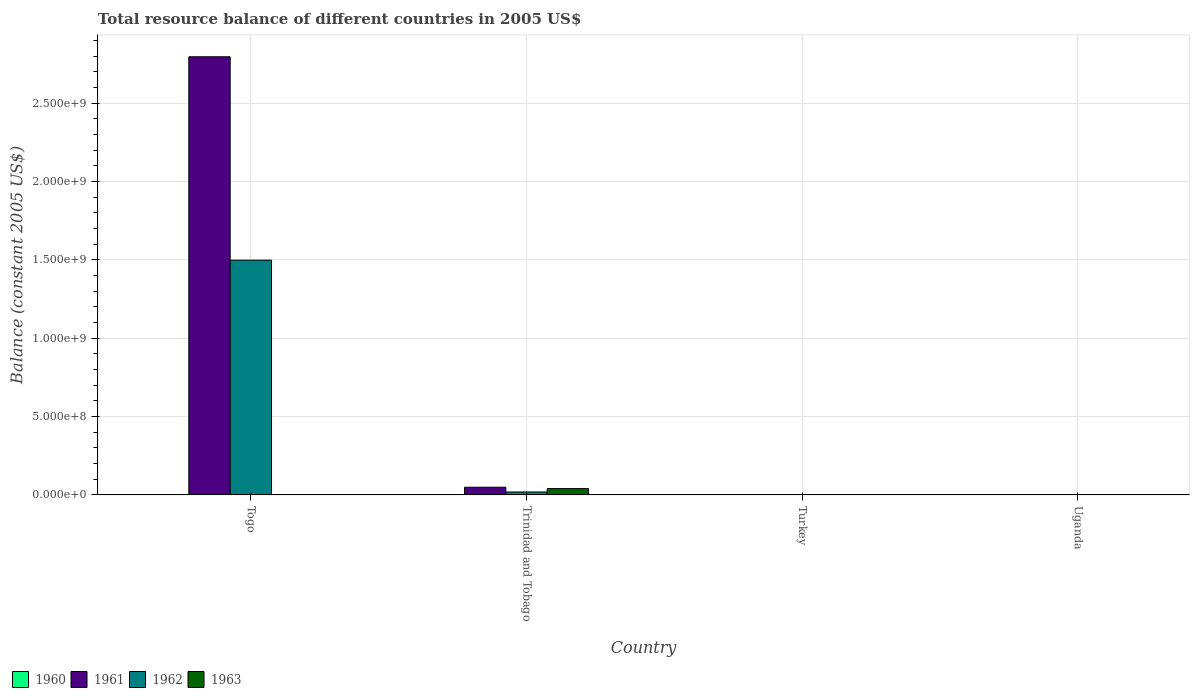How many different coloured bars are there?
Provide a succinct answer. 4. Are the number of bars on each tick of the X-axis equal?
Keep it short and to the point. No. How many bars are there on the 1st tick from the left?
Provide a short and direct response. 2. What is the total resource balance in 1963 in Uganda?
Make the answer very short. 2.17e+06. Across all countries, what is the maximum total resource balance in 1961?
Your answer should be compact. 2.80e+09. In which country was the total resource balance in 1962 maximum?
Provide a short and direct response. Togo. What is the total total resource balance in 1962 in the graph?
Your answer should be very brief. 1.52e+09. What is the difference between the total resource balance in 1963 in Trinidad and Tobago and that in Uganda?
Your answer should be compact. 3.81e+07. What is the difference between the total resource balance in 1962 in Trinidad and Tobago and the total resource balance in 1963 in Uganda?
Give a very brief answer. 1.64e+07. What is the average total resource balance in 1962 per country?
Offer a terse response. 3.79e+08. What is the difference between the total resource balance of/in 1961 and total resource balance of/in 1963 in Trinidad and Tobago?
Your response must be concise. 8.50e+06. What is the ratio of the total resource balance in 1961 in Togo to that in Trinidad and Tobago?
Your response must be concise. 57.29. What is the difference between the highest and the second highest total resource balance in 1961?
Make the answer very short. -2.75e+09. What is the difference between the highest and the lowest total resource balance in 1961?
Ensure brevity in your answer.  2.80e+09. In how many countries, is the total resource balance in 1961 greater than the average total resource balance in 1961 taken over all countries?
Ensure brevity in your answer.  1. Is it the case that in every country, the sum of the total resource balance in 1960 and total resource balance in 1962 is greater than the total resource balance in 1963?
Keep it short and to the point. No. How many bars are there?
Make the answer very short. 9. Are all the bars in the graph horizontal?
Provide a short and direct response. No. How many countries are there in the graph?
Keep it short and to the point. 4. What is the difference between two consecutive major ticks on the Y-axis?
Your answer should be very brief. 5.00e+08. Are the values on the major ticks of Y-axis written in scientific E-notation?
Your answer should be compact. Yes. Does the graph contain any zero values?
Your answer should be compact. Yes. Does the graph contain grids?
Keep it short and to the point. Yes. Where does the legend appear in the graph?
Offer a very short reply. Bottom left. How many legend labels are there?
Provide a succinct answer. 4. What is the title of the graph?
Offer a terse response. Total resource balance of different countries in 2005 US$. Does "1997" appear as one of the legend labels in the graph?
Offer a terse response. No. What is the label or title of the X-axis?
Provide a short and direct response. Country. What is the label or title of the Y-axis?
Give a very brief answer. Balance (constant 2005 US$). What is the Balance (constant 2005 US$) in 1961 in Togo?
Give a very brief answer. 2.80e+09. What is the Balance (constant 2005 US$) in 1962 in Togo?
Provide a succinct answer. 1.50e+09. What is the Balance (constant 2005 US$) of 1963 in Togo?
Give a very brief answer. 0. What is the Balance (constant 2005 US$) of 1961 in Trinidad and Tobago?
Offer a very short reply. 4.88e+07. What is the Balance (constant 2005 US$) in 1962 in Trinidad and Tobago?
Offer a terse response. 1.86e+07. What is the Balance (constant 2005 US$) of 1963 in Trinidad and Tobago?
Your answer should be very brief. 4.03e+07. What is the Balance (constant 2005 US$) of 1960 in Turkey?
Provide a succinct answer. 0. What is the Balance (constant 2005 US$) in 1961 in Turkey?
Your answer should be very brief. 0. What is the Balance (constant 2005 US$) in 1963 in Turkey?
Offer a very short reply. 0. What is the Balance (constant 2005 US$) of 1960 in Uganda?
Provide a succinct answer. 2.22e+06. What is the Balance (constant 2005 US$) in 1961 in Uganda?
Your answer should be compact. 1.17e+06. What is the Balance (constant 2005 US$) of 1962 in Uganda?
Make the answer very short. 1.14e+06. What is the Balance (constant 2005 US$) of 1963 in Uganda?
Your response must be concise. 2.17e+06. Across all countries, what is the maximum Balance (constant 2005 US$) in 1960?
Your answer should be compact. 2.22e+06. Across all countries, what is the maximum Balance (constant 2005 US$) of 1961?
Provide a succinct answer. 2.80e+09. Across all countries, what is the maximum Balance (constant 2005 US$) in 1962?
Provide a succinct answer. 1.50e+09. Across all countries, what is the maximum Balance (constant 2005 US$) in 1963?
Make the answer very short. 4.03e+07. Across all countries, what is the minimum Balance (constant 2005 US$) in 1963?
Ensure brevity in your answer.  0. What is the total Balance (constant 2005 US$) in 1960 in the graph?
Offer a terse response. 2.22e+06. What is the total Balance (constant 2005 US$) in 1961 in the graph?
Your answer should be compact. 2.85e+09. What is the total Balance (constant 2005 US$) in 1962 in the graph?
Give a very brief answer. 1.52e+09. What is the total Balance (constant 2005 US$) of 1963 in the graph?
Ensure brevity in your answer.  4.25e+07. What is the difference between the Balance (constant 2005 US$) in 1961 in Togo and that in Trinidad and Tobago?
Give a very brief answer. 2.75e+09. What is the difference between the Balance (constant 2005 US$) of 1962 in Togo and that in Trinidad and Tobago?
Provide a short and direct response. 1.48e+09. What is the difference between the Balance (constant 2005 US$) in 1961 in Togo and that in Uganda?
Your answer should be compact. 2.79e+09. What is the difference between the Balance (constant 2005 US$) in 1962 in Togo and that in Uganda?
Your answer should be compact. 1.50e+09. What is the difference between the Balance (constant 2005 US$) in 1961 in Trinidad and Tobago and that in Uganda?
Your response must be concise. 4.76e+07. What is the difference between the Balance (constant 2005 US$) of 1962 in Trinidad and Tobago and that in Uganda?
Give a very brief answer. 1.75e+07. What is the difference between the Balance (constant 2005 US$) of 1963 in Trinidad and Tobago and that in Uganda?
Offer a very short reply. 3.81e+07. What is the difference between the Balance (constant 2005 US$) in 1961 in Togo and the Balance (constant 2005 US$) in 1962 in Trinidad and Tobago?
Your answer should be compact. 2.78e+09. What is the difference between the Balance (constant 2005 US$) in 1961 in Togo and the Balance (constant 2005 US$) in 1963 in Trinidad and Tobago?
Keep it short and to the point. 2.76e+09. What is the difference between the Balance (constant 2005 US$) in 1962 in Togo and the Balance (constant 2005 US$) in 1963 in Trinidad and Tobago?
Your answer should be very brief. 1.46e+09. What is the difference between the Balance (constant 2005 US$) of 1961 in Togo and the Balance (constant 2005 US$) of 1962 in Uganda?
Give a very brief answer. 2.79e+09. What is the difference between the Balance (constant 2005 US$) in 1961 in Togo and the Balance (constant 2005 US$) in 1963 in Uganda?
Your response must be concise. 2.79e+09. What is the difference between the Balance (constant 2005 US$) of 1962 in Togo and the Balance (constant 2005 US$) of 1963 in Uganda?
Provide a succinct answer. 1.50e+09. What is the difference between the Balance (constant 2005 US$) in 1961 in Trinidad and Tobago and the Balance (constant 2005 US$) in 1962 in Uganda?
Provide a short and direct response. 4.77e+07. What is the difference between the Balance (constant 2005 US$) in 1961 in Trinidad and Tobago and the Balance (constant 2005 US$) in 1963 in Uganda?
Offer a terse response. 4.66e+07. What is the difference between the Balance (constant 2005 US$) in 1962 in Trinidad and Tobago and the Balance (constant 2005 US$) in 1963 in Uganda?
Provide a succinct answer. 1.64e+07. What is the average Balance (constant 2005 US$) of 1960 per country?
Offer a very short reply. 5.56e+05. What is the average Balance (constant 2005 US$) of 1961 per country?
Your response must be concise. 7.11e+08. What is the average Balance (constant 2005 US$) of 1962 per country?
Provide a short and direct response. 3.79e+08. What is the average Balance (constant 2005 US$) of 1963 per country?
Provide a succinct answer. 1.06e+07. What is the difference between the Balance (constant 2005 US$) in 1961 and Balance (constant 2005 US$) in 1962 in Togo?
Give a very brief answer. 1.30e+09. What is the difference between the Balance (constant 2005 US$) in 1961 and Balance (constant 2005 US$) in 1962 in Trinidad and Tobago?
Keep it short and to the point. 3.02e+07. What is the difference between the Balance (constant 2005 US$) in 1961 and Balance (constant 2005 US$) in 1963 in Trinidad and Tobago?
Ensure brevity in your answer.  8.50e+06. What is the difference between the Balance (constant 2005 US$) in 1962 and Balance (constant 2005 US$) in 1963 in Trinidad and Tobago?
Keep it short and to the point. -2.17e+07. What is the difference between the Balance (constant 2005 US$) of 1960 and Balance (constant 2005 US$) of 1961 in Uganda?
Provide a succinct answer. 1.06e+06. What is the difference between the Balance (constant 2005 US$) of 1960 and Balance (constant 2005 US$) of 1962 in Uganda?
Offer a terse response. 1.09e+06. What is the difference between the Balance (constant 2005 US$) in 1960 and Balance (constant 2005 US$) in 1963 in Uganda?
Give a very brief answer. 5.31e+04. What is the difference between the Balance (constant 2005 US$) of 1961 and Balance (constant 2005 US$) of 1962 in Uganda?
Provide a succinct answer. 2.93e+04. What is the difference between the Balance (constant 2005 US$) of 1961 and Balance (constant 2005 US$) of 1963 in Uganda?
Provide a succinct answer. -1.00e+06. What is the difference between the Balance (constant 2005 US$) of 1962 and Balance (constant 2005 US$) of 1963 in Uganda?
Provide a succinct answer. -1.03e+06. What is the ratio of the Balance (constant 2005 US$) of 1961 in Togo to that in Trinidad and Tobago?
Keep it short and to the point. 57.29. What is the ratio of the Balance (constant 2005 US$) of 1962 in Togo to that in Trinidad and Tobago?
Your answer should be compact. 80.54. What is the ratio of the Balance (constant 2005 US$) of 1961 in Togo to that in Uganda?
Your answer should be compact. 2392.37. What is the ratio of the Balance (constant 2005 US$) in 1962 in Togo to that in Uganda?
Your answer should be very brief. 1314.75. What is the ratio of the Balance (constant 2005 US$) in 1961 in Trinidad and Tobago to that in Uganda?
Keep it short and to the point. 41.76. What is the ratio of the Balance (constant 2005 US$) of 1962 in Trinidad and Tobago to that in Uganda?
Your response must be concise. 16.32. What is the ratio of the Balance (constant 2005 US$) of 1963 in Trinidad and Tobago to that in Uganda?
Your answer should be very brief. 18.56. What is the difference between the highest and the second highest Balance (constant 2005 US$) of 1961?
Provide a succinct answer. 2.75e+09. What is the difference between the highest and the second highest Balance (constant 2005 US$) in 1962?
Offer a very short reply. 1.48e+09. What is the difference between the highest and the lowest Balance (constant 2005 US$) of 1960?
Offer a very short reply. 2.22e+06. What is the difference between the highest and the lowest Balance (constant 2005 US$) in 1961?
Offer a terse response. 2.80e+09. What is the difference between the highest and the lowest Balance (constant 2005 US$) of 1962?
Your answer should be very brief. 1.50e+09. What is the difference between the highest and the lowest Balance (constant 2005 US$) of 1963?
Provide a succinct answer. 4.03e+07. 